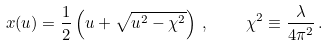Convert formula to latex. <formula><loc_0><loc_0><loc_500><loc_500>x ( u ) = \frac { 1 } { 2 } \left ( u + \sqrt { u ^ { 2 } - \chi ^ { 2 } } \right ) \, , \quad \chi ^ { 2 } \equiv \frac { \lambda } { 4 \pi ^ { 2 } } \, .</formula> 